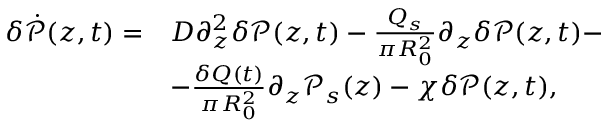Convert formula to latex. <formula><loc_0><loc_0><loc_500><loc_500>\begin{array} { r l } { \delta \dot { \mathcal { P } } ( z , t ) = } & { D \partial _ { z } ^ { 2 } \delta \mathcal { P } ( z , t ) - \frac { Q _ { s } } { \pi R _ { 0 } ^ { 2 } } \partial _ { z } \delta \mathcal { P } ( z , t ) - } \\ & { - \frac { \delta Q ( t ) } { \pi R _ { 0 } ^ { 2 } } \partial _ { z } \mathcal { P } _ { s } ( z ) - \chi \delta \mathcal { P } ( z , t ) , } \end{array}</formula> 